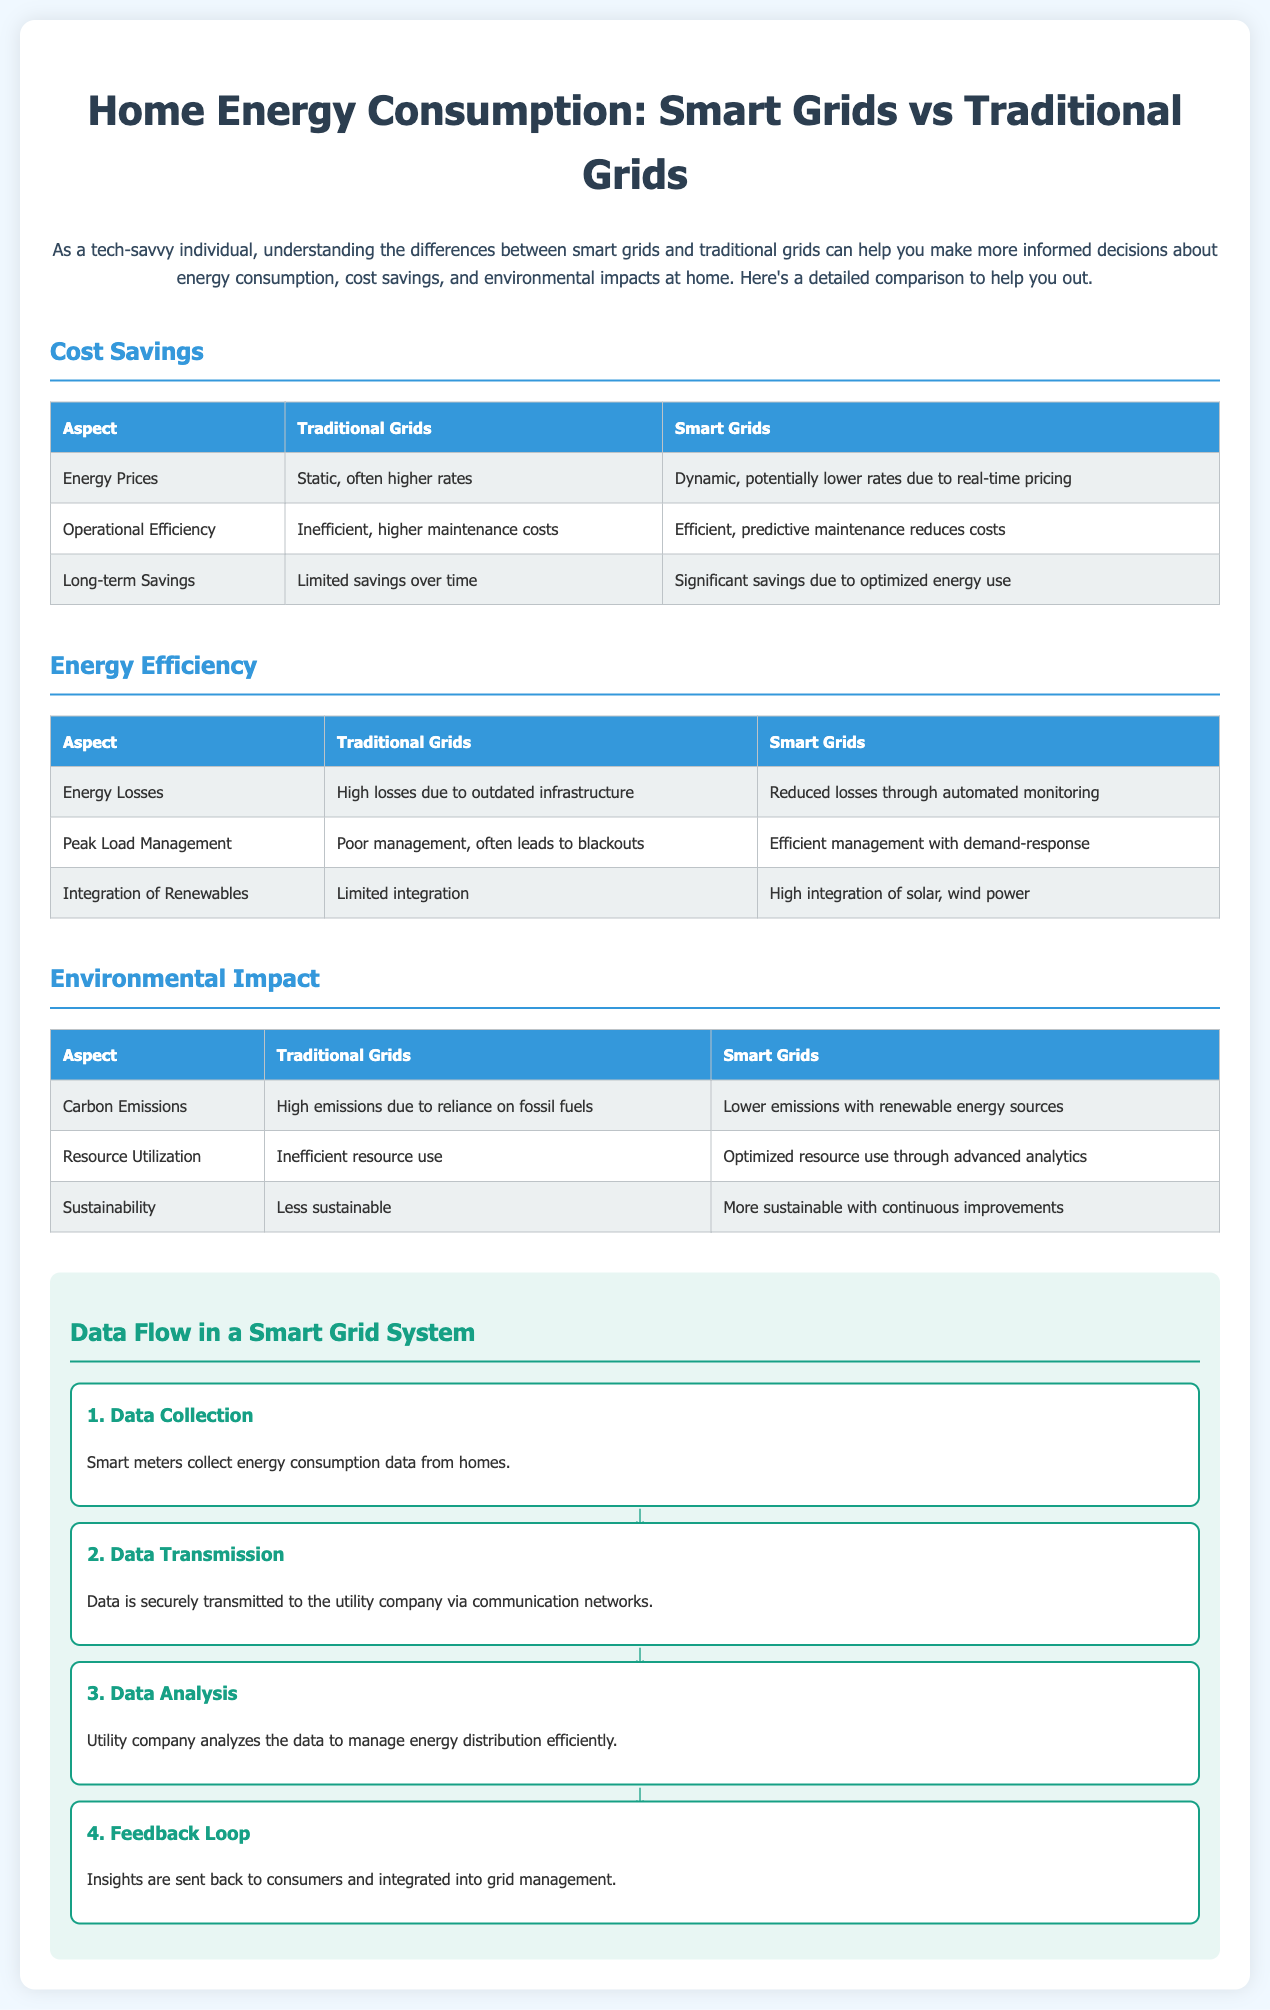What type of energy prices do traditional grids have? Traditional grids have static energy prices, often resulting in higher rates.
Answer: Static, often higher rates Which grid type offers significant long-term savings? The document states that smart grids provide significant savings due to optimized energy use.
Answer: Smart Grids What aspect of energy losses is higher in traditional grids? The table indicates that traditional grids have high losses due to outdated infrastructure.
Answer: High losses Which grid has better integration of renewable sources? It is noted in the document that smart grids have high integration of solar and wind power.
Answer: Smart Grids What is the first step in the smart grid data flow? The first step is data collection, where smart meters collect consumption data.
Answer: Data Collection How do smart grids manage peak load compared to traditional grids? Smart grids efficiently manage peak loads with demand-response strategies, unlike traditional grids that manage poorly.
Answer: Efficient management What are the carbon emissions associated with traditional grids? The document describes traditional grids as having high carbon emissions due to fossil fuel reliance.
Answer: High emissions What is the document type? Given the structure and content, it represents a comparison infographic with charts.
Answer: Infographic with charts What kind of efficiency do smart grids offer compared to traditional grids? Smart grids are described as efficient due to predictive maintenance, while traditional grids are inefficient.
Answer: Efficient 